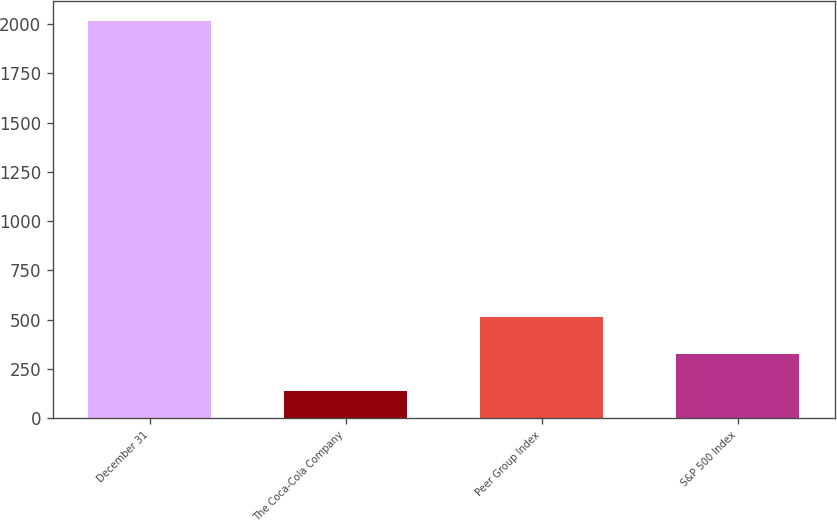<chart> <loc_0><loc_0><loc_500><loc_500><bar_chart><fcel>December 31<fcel>The Coca-Cola Company<fcel>Peer Group Index<fcel>S&P 500 Index<nl><fcel>2015<fcel>138<fcel>513.4<fcel>325.7<nl></chart> 